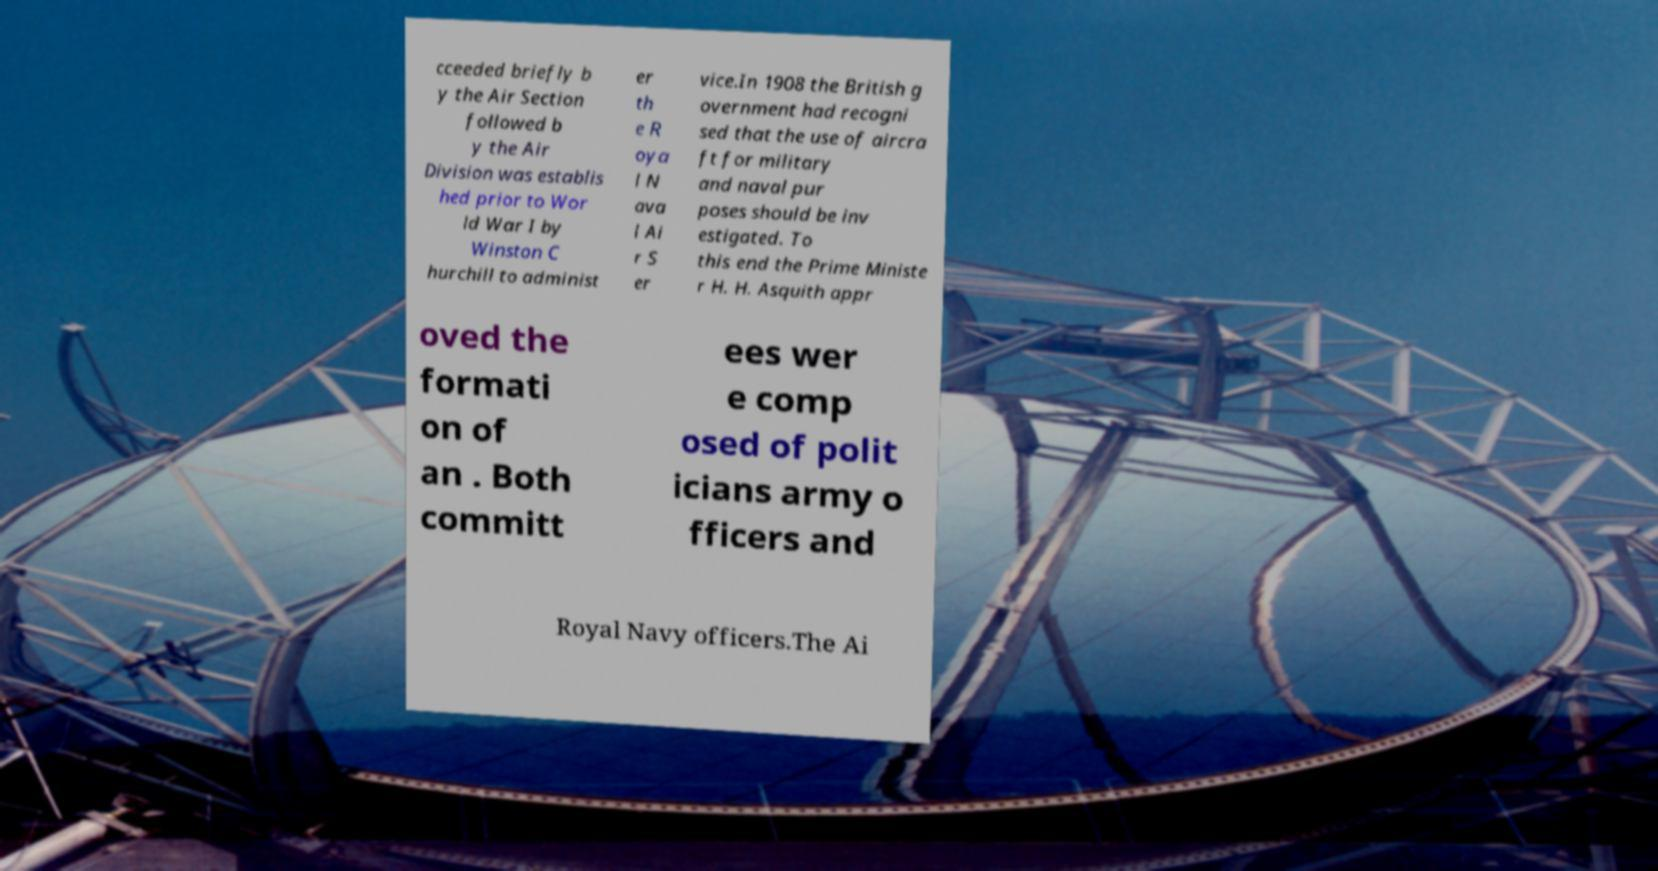Please identify and transcribe the text found in this image. cceeded briefly b y the Air Section followed b y the Air Division was establis hed prior to Wor ld War I by Winston C hurchill to administ er th e R oya l N ava l Ai r S er vice.In 1908 the British g overnment had recogni sed that the use of aircra ft for military and naval pur poses should be inv estigated. To this end the Prime Ministe r H. H. Asquith appr oved the formati on of an . Both committ ees wer e comp osed of polit icians army o fficers and Royal Navy officers.The Ai 